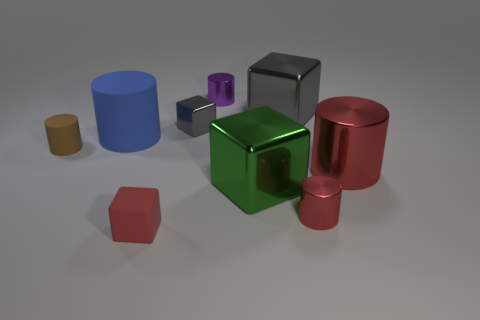Subtract 2 blocks. How many blocks are left? 2 Subtract all blue cylinders. How many cylinders are left? 4 Add 1 blue cylinders. How many objects exist? 10 Subtract all purple cylinders. How many cylinders are left? 4 Subtract all brown cylinders. How many gray cubes are left? 2 Subtract all cylinders. How many objects are left? 4 Add 1 big red shiny cylinders. How many big red shiny cylinders exist? 2 Subtract 0 brown balls. How many objects are left? 9 Subtract all cyan cubes. Subtract all gray cylinders. How many cubes are left? 4 Subtract all small gray things. Subtract all big red cylinders. How many objects are left? 7 